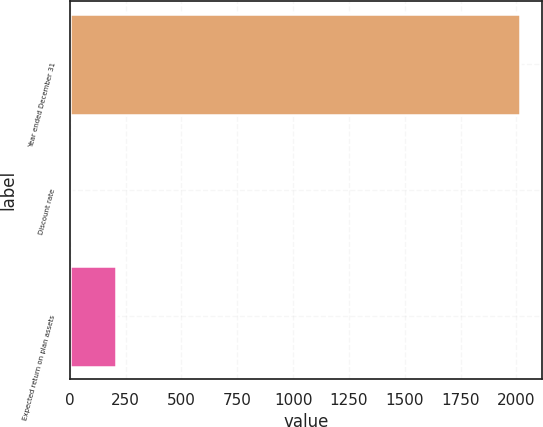<chart> <loc_0><loc_0><loc_500><loc_500><bar_chart><fcel>Year ended December 31<fcel>Discount rate<fcel>Expected return on plan assets<nl><fcel>2016<fcel>3.75<fcel>204.98<nl></chart> 